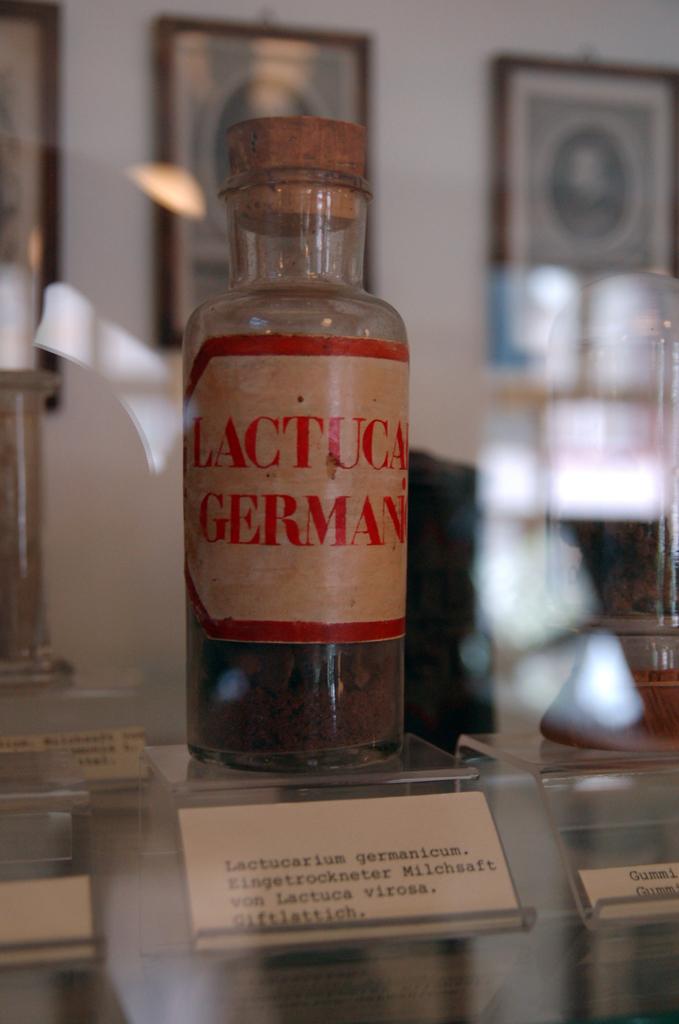What is written on that label?
Offer a very short reply. Lactuca german. 